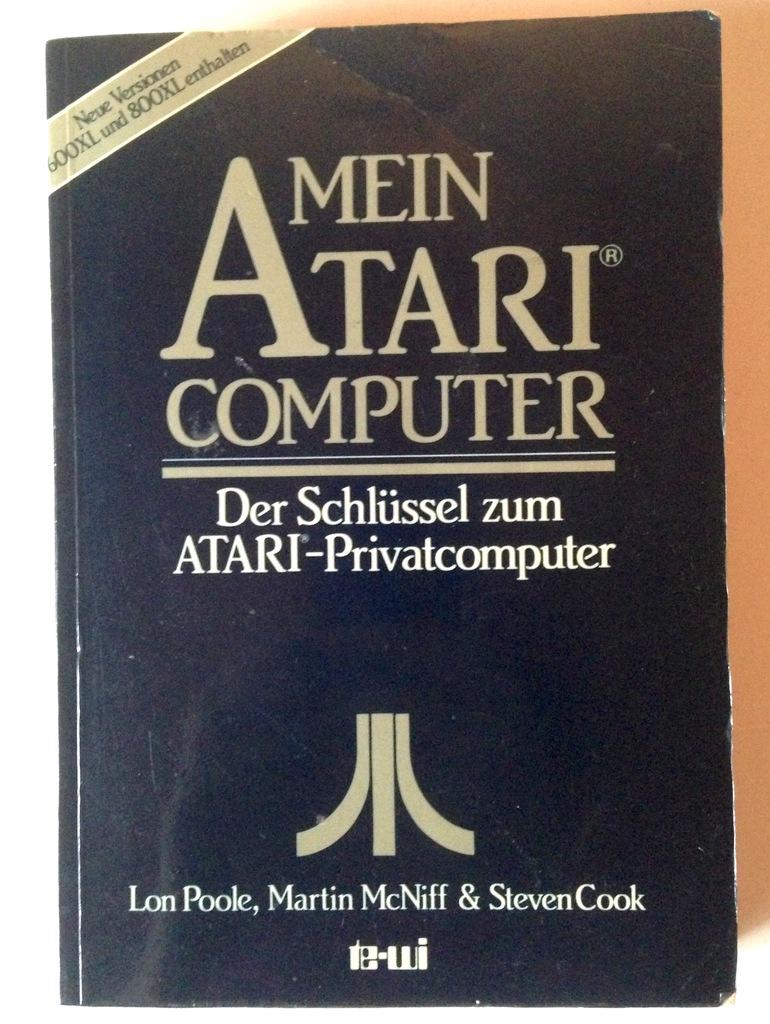What is the name of the book?
Make the answer very short. Mein atari computer. 